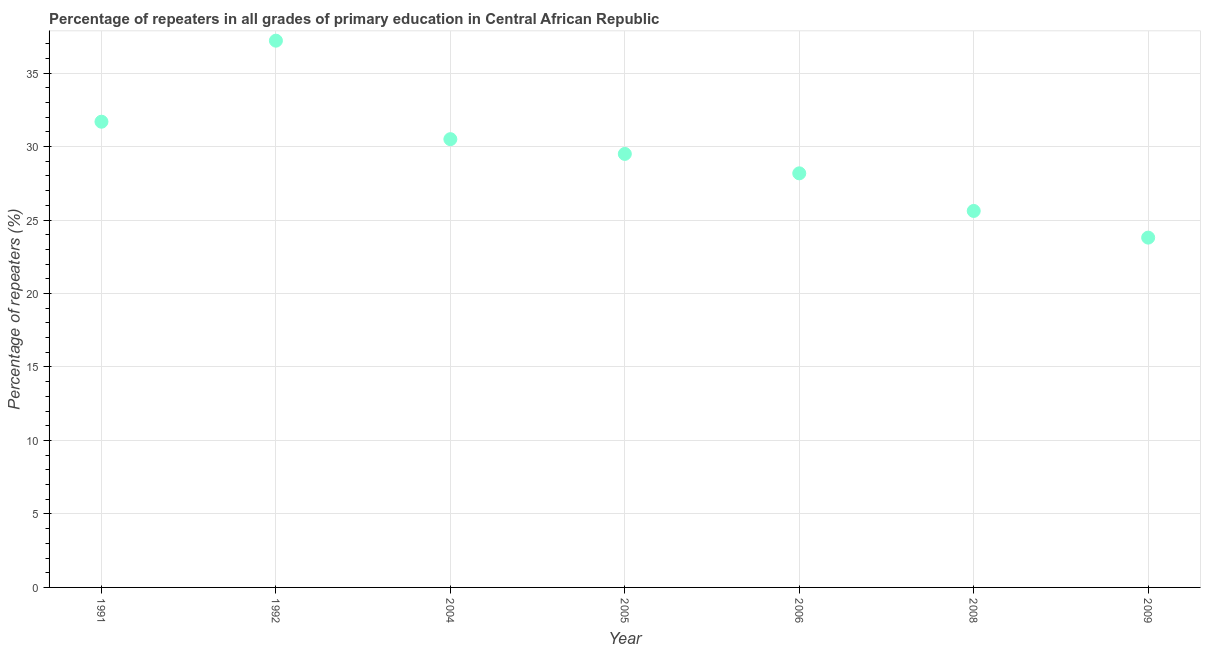What is the percentage of repeaters in primary education in 2008?
Offer a terse response. 25.62. Across all years, what is the maximum percentage of repeaters in primary education?
Ensure brevity in your answer.  37.2. Across all years, what is the minimum percentage of repeaters in primary education?
Offer a terse response. 23.8. In which year was the percentage of repeaters in primary education maximum?
Ensure brevity in your answer.  1992. In which year was the percentage of repeaters in primary education minimum?
Your answer should be compact. 2009. What is the sum of the percentage of repeaters in primary education?
Provide a succinct answer. 206.49. What is the difference between the percentage of repeaters in primary education in 1991 and 2008?
Give a very brief answer. 6.07. What is the average percentage of repeaters in primary education per year?
Provide a short and direct response. 29.5. What is the median percentage of repeaters in primary education?
Offer a very short reply. 29.5. Do a majority of the years between 1991 and 2004 (inclusive) have percentage of repeaters in primary education greater than 17 %?
Provide a short and direct response. Yes. What is the ratio of the percentage of repeaters in primary education in 1991 to that in 2009?
Give a very brief answer. 1.33. Is the percentage of repeaters in primary education in 2004 less than that in 2008?
Provide a short and direct response. No. Is the difference between the percentage of repeaters in primary education in 1992 and 2004 greater than the difference between any two years?
Ensure brevity in your answer.  No. What is the difference between the highest and the second highest percentage of repeaters in primary education?
Your answer should be compact. 5.51. Is the sum of the percentage of repeaters in primary education in 1991 and 2005 greater than the maximum percentage of repeaters in primary education across all years?
Your answer should be very brief. Yes. What is the difference between the highest and the lowest percentage of repeaters in primary education?
Your answer should be compact. 13.4. In how many years, is the percentage of repeaters in primary education greater than the average percentage of repeaters in primary education taken over all years?
Make the answer very short. 4. How many dotlines are there?
Your answer should be compact. 1. Does the graph contain grids?
Offer a terse response. Yes. What is the title of the graph?
Ensure brevity in your answer.  Percentage of repeaters in all grades of primary education in Central African Republic. What is the label or title of the Y-axis?
Offer a very short reply. Percentage of repeaters (%). What is the Percentage of repeaters (%) in 1991?
Your response must be concise. 31.69. What is the Percentage of repeaters (%) in 1992?
Ensure brevity in your answer.  37.2. What is the Percentage of repeaters (%) in 2004?
Your answer should be compact. 30.5. What is the Percentage of repeaters (%) in 2005?
Your answer should be very brief. 29.5. What is the Percentage of repeaters (%) in 2006?
Provide a succinct answer. 28.18. What is the Percentage of repeaters (%) in 2008?
Ensure brevity in your answer.  25.62. What is the Percentage of repeaters (%) in 2009?
Make the answer very short. 23.8. What is the difference between the Percentage of repeaters (%) in 1991 and 1992?
Ensure brevity in your answer.  -5.51. What is the difference between the Percentage of repeaters (%) in 1991 and 2004?
Ensure brevity in your answer.  1.19. What is the difference between the Percentage of repeaters (%) in 1991 and 2005?
Your response must be concise. 2.19. What is the difference between the Percentage of repeaters (%) in 1991 and 2006?
Make the answer very short. 3.51. What is the difference between the Percentage of repeaters (%) in 1991 and 2008?
Make the answer very short. 6.07. What is the difference between the Percentage of repeaters (%) in 1991 and 2009?
Your answer should be compact. 7.89. What is the difference between the Percentage of repeaters (%) in 1992 and 2004?
Make the answer very short. 6.7. What is the difference between the Percentage of repeaters (%) in 1992 and 2005?
Offer a very short reply. 7.7. What is the difference between the Percentage of repeaters (%) in 1992 and 2006?
Your answer should be very brief. 9.03. What is the difference between the Percentage of repeaters (%) in 1992 and 2008?
Offer a terse response. 11.59. What is the difference between the Percentage of repeaters (%) in 1992 and 2009?
Give a very brief answer. 13.4. What is the difference between the Percentage of repeaters (%) in 2004 and 2005?
Ensure brevity in your answer.  1. What is the difference between the Percentage of repeaters (%) in 2004 and 2006?
Offer a very short reply. 2.32. What is the difference between the Percentage of repeaters (%) in 2004 and 2008?
Ensure brevity in your answer.  4.88. What is the difference between the Percentage of repeaters (%) in 2004 and 2009?
Provide a succinct answer. 6.7. What is the difference between the Percentage of repeaters (%) in 2005 and 2006?
Ensure brevity in your answer.  1.32. What is the difference between the Percentage of repeaters (%) in 2005 and 2008?
Provide a short and direct response. 3.88. What is the difference between the Percentage of repeaters (%) in 2005 and 2009?
Ensure brevity in your answer.  5.7. What is the difference between the Percentage of repeaters (%) in 2006 and 2008?
Provide a succinct answer. 2.56. What is the difference between the Percentage of repeaters (%) in 2006 and 2009?
Offer a terse response. 4.37. What is the difference between the Percentage of repeaters (%) in 2008 and 2009?
Your answer should be very brief. 1.81. What is the ratio of the Percentage of repeaters (%) in 1991 to that in 1992?
Provide a succinct answer. 0.85. What is the ratio of the Percentage of repeaters (%) in 1991 to that in 2004?
Offer a terse response. 1.04. What is the ratio of the Percentage of repeaters (%) in 1991 to that in 2005?
Provide a succinct answer. 1.07. What is the ratio of the Percentage of repeaters (%) in 1991 to that in 2008?
Your answer should be very brief. 1.24. What is the ratio of the Percentage of repeaters (%) in 1991 to that in 2009?
Give a very brief answer. 1.33. What is the ratio of the Percentage of repeaters (%) in 1992 to that in 2004?
Provide a succinct answer. 1.22. What is the ratio of the Percentage of repeaters (%) in 1992 to that in 2005?
Keep it short and to the point. 1.26. What is the ratio of the Percentage of repeaters (%) in 1992 to that in 2006?
Offer a very short reply. 1.32. What is the ratio of the Percentage of repeaters (%) in 1992 to that in 2008?
Ensure brevity in your answer.  1.45. What is the ratio of the Percentage of repeaters (%) in 1992 to that in 2009?
Offer a terse response. 1.56. What is the ratio of the Percentage of repeaters (%) in 2004 to that in 2005?
Give a very brief answer. 1.03. What is the ratio of the Percentage of repeaters (%) in 2004 to that in 2006?
Your response must be concise. 1.08. What is the ratio of the Percentage of repeaters (%) in 2004 to that in 2008?
Offer a very short reply. 1.19. What is the ratio of the Percentage of repeaters (%) in 2004 to that in 2009?
Make the answer very short. 1.28. What is the ratio of the Percentage of repeaters (%) in 2005 to that in 2006?
Your answer should be very brief. 1.05. What is the ratio of the Percentage of repeaters (%) in 2005 to that in 2008?
Provide a succinct answer. 1.15. What is the ratio of the Percentage of repeaters (%) in 2005 to that in 2009?
Offer a terse response. 1.24. What is the ratio of the Percentage of repeaters (%) in 2006 to that in 2009?
Keep it short and to the point. 1.18. What is the ratio of the Percentage of repeaters (%) in 2008 to that in 2009?
Make the answer very short. 1.08. 